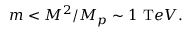Convert formula to latex. <formula><loc_0><loc_0><loc_500><loc_500>m < { M ^ { 2 } / M _ { p } } \sim 1 { T e V } .</formula> 